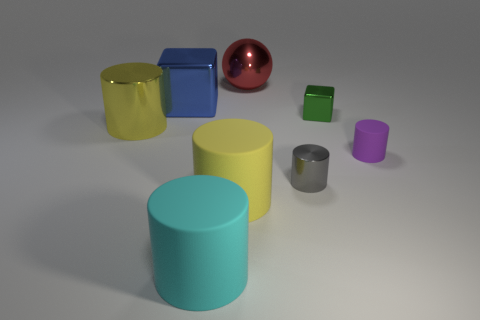Is the color of the big object that is to the left of the blue cube the same as the metallic ball?
Offer a terse response. No. What material is the cyan object that is the same shape as the tiny purple thing?
Your answer should be compact. Rubber. How many rubber objects are the same size as the yellow shiny thing?
Make the answer very short. 2. What shape is the big yellow rubber object?
Provide a succinct answer. Cylinder. There is a shiny thing that is both on the left side of the gray metallic object and to the right of the large shiny block; what size is it?
Make the answer very short. Large. What is the material of the large yellow thing that is in front of the yellow metal cylinder?
Your answer should be very brief. Rubber. Do the metal ball and the shiny thing in front of the big yellow metal object have the same color?
Ensure brevity in your answer.  No. What number of things are big shiny things that are in front of the shiny ball or metal blocks to the right of the big cyan thing?
Provide a succinct answer. 3. What color is the cylinder that is both left of the big shiny sphere and behind the tiny gray thing?
Your response must be concise. Yellow. Is the number of small green objects greater than the number of purple metal cylinders?
Keep it short and to the point. Yes. 